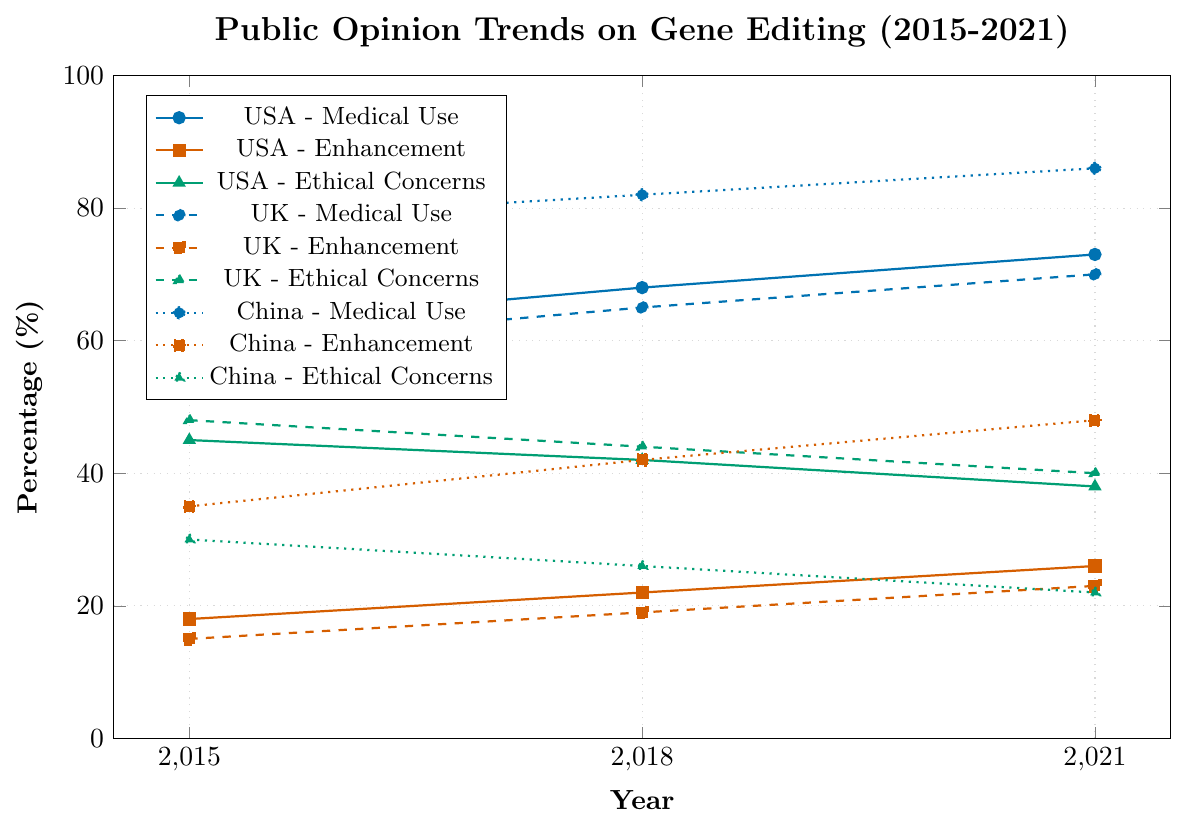What's the percentage increase in support for medical use of gene editing in the United States from 2015 to 2021? The percentage in 2015 is 62% and in 2021 it is 73%, so the increase is 73% - 62% = 11 percentage points.
Answer: 11 percentage points Which country had the highest support for gene editing for enhancement purposes in 2021? By looking at the enhancement support data for 2021, China shows the highest support with 48%.
Answer: China How did the ethical concerns about gene editing in the United Kingdom change from 2015 to 2021? The ethical concerns in the UK were 48% in 2015 and dropped to 40% in 2021, indicating a decrease.
Answer: Decreased Compare the support for medical use of gene editing in the United States and Canada in 2021. In 2021, the support for medical use in the USA is 73%, while in Canada it is 72%. Thus, the USA has slightly higher support.
Answer: USA has higher support What is the average percentage of support for medical use of gene editing in Australia across the years 2015, 2018, and 2021? The percentages are 60% in 2015, 66% in 2018, and 71% in 2021. The average is (60 + 66 + 71) / 3 = 65.67%.
Answer: 65.67% Between 2015 and 2021, which country displayed the largest decline in ethical concerns about gene editing? Comparing the decline, China had the largest decrease in ethical concerns, from 30% in 2015 to 22% in 2021.
Answer: China What is the trend in the support for enhancement use of gene editing in Germany from 2015 to 2021? The support in Germany increased from 12% in 2015 to 20% in 2021, indicating a steady upward trend.
Answer: Upward trend By how much did support for medical use of gene editing increase in Japan from 2015 to 2021? In Japan, the support increased from 58% in 2015 to 68% in 2021, so the increase is 10 percentage points.
Answer: 10 percentage points Compare the trends in ethical concerns for gene editing in the United States and China from 2015 to 2021. In the USA, ethical concerns decreased from 45% to 38%, while in China they decreased from 30% to 22%. Both countries show a downward trend, but China has a steeper decline.
Answer: Both decreased, China steeper 